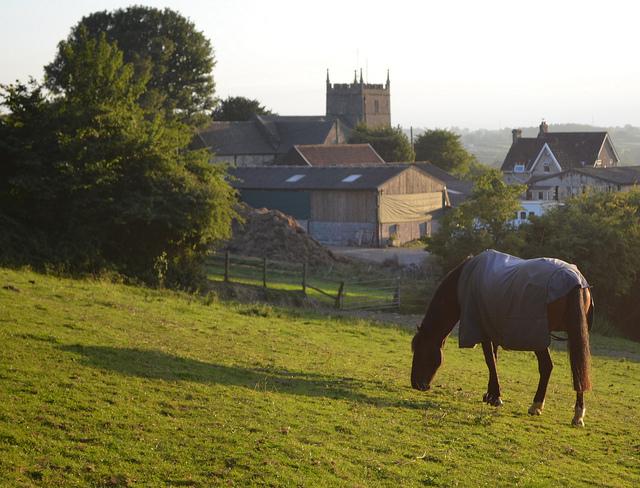What is behind the horse?
Give a very brief answer. Tree. Is the horse albino?
Answer briefly. No. Is the picture in color?
Answer briefly. Yes. What kind of animal's are there?
Keep it brief. Horse. What color is this horse?
Concise answer only. Brown. What is this animal?
Short answer required. Horse. Is there a plane in the sky?
Quick response, please. No. Is the grass nice and healthy?
Be succinct. Yes. Is it sunset?
Answer briefly. No. What object is in the background?
Write a very short answer. House. How many horses are there?
Keep it brief. 1. Is the animal shown someone's pet?
Be succinct. Yes. What kind of trees are in the field?
Quick response, please. Oak. Is this in the sand?
Write a very short answer. No. Can the horse freely reach the house in the distance?
Answer briefly. No. What kind of wire is pictured?
Write a very short answer. None. How many horses are in the picture?
Answer briefly. 1. Is this in the countryside?
Quick response, please. Yes. Is this habitat controlled?
Answer briefly. Yes. What side of the horse is the shadow?
Write a very short answer. Left. What kind of horse is this?
Write a very short answer. Brown. Does this scene take place in the city or country?
Answer briefly. Country. Is this photo more than 10 years old?
Be succinct. No. 